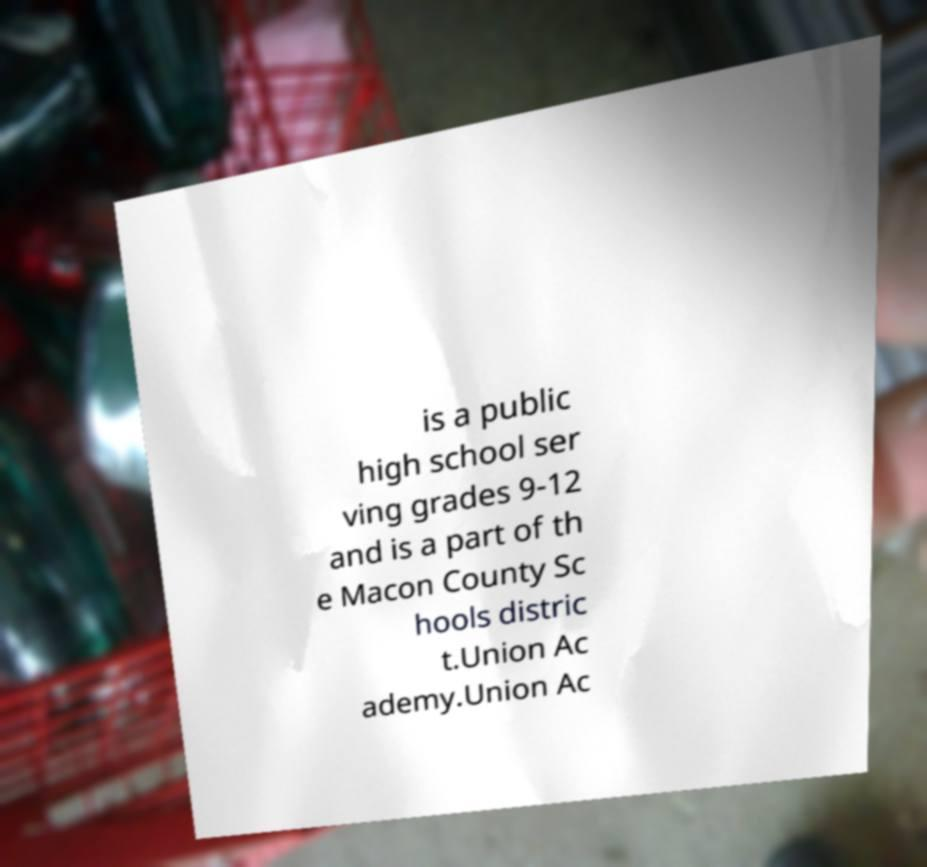Please identify and transcribe the text found in this image. is a public high school ser ving grades 9-12 and is a part of th e Macon County Sc hools distric t.Union Ac ademy.Union Ac 